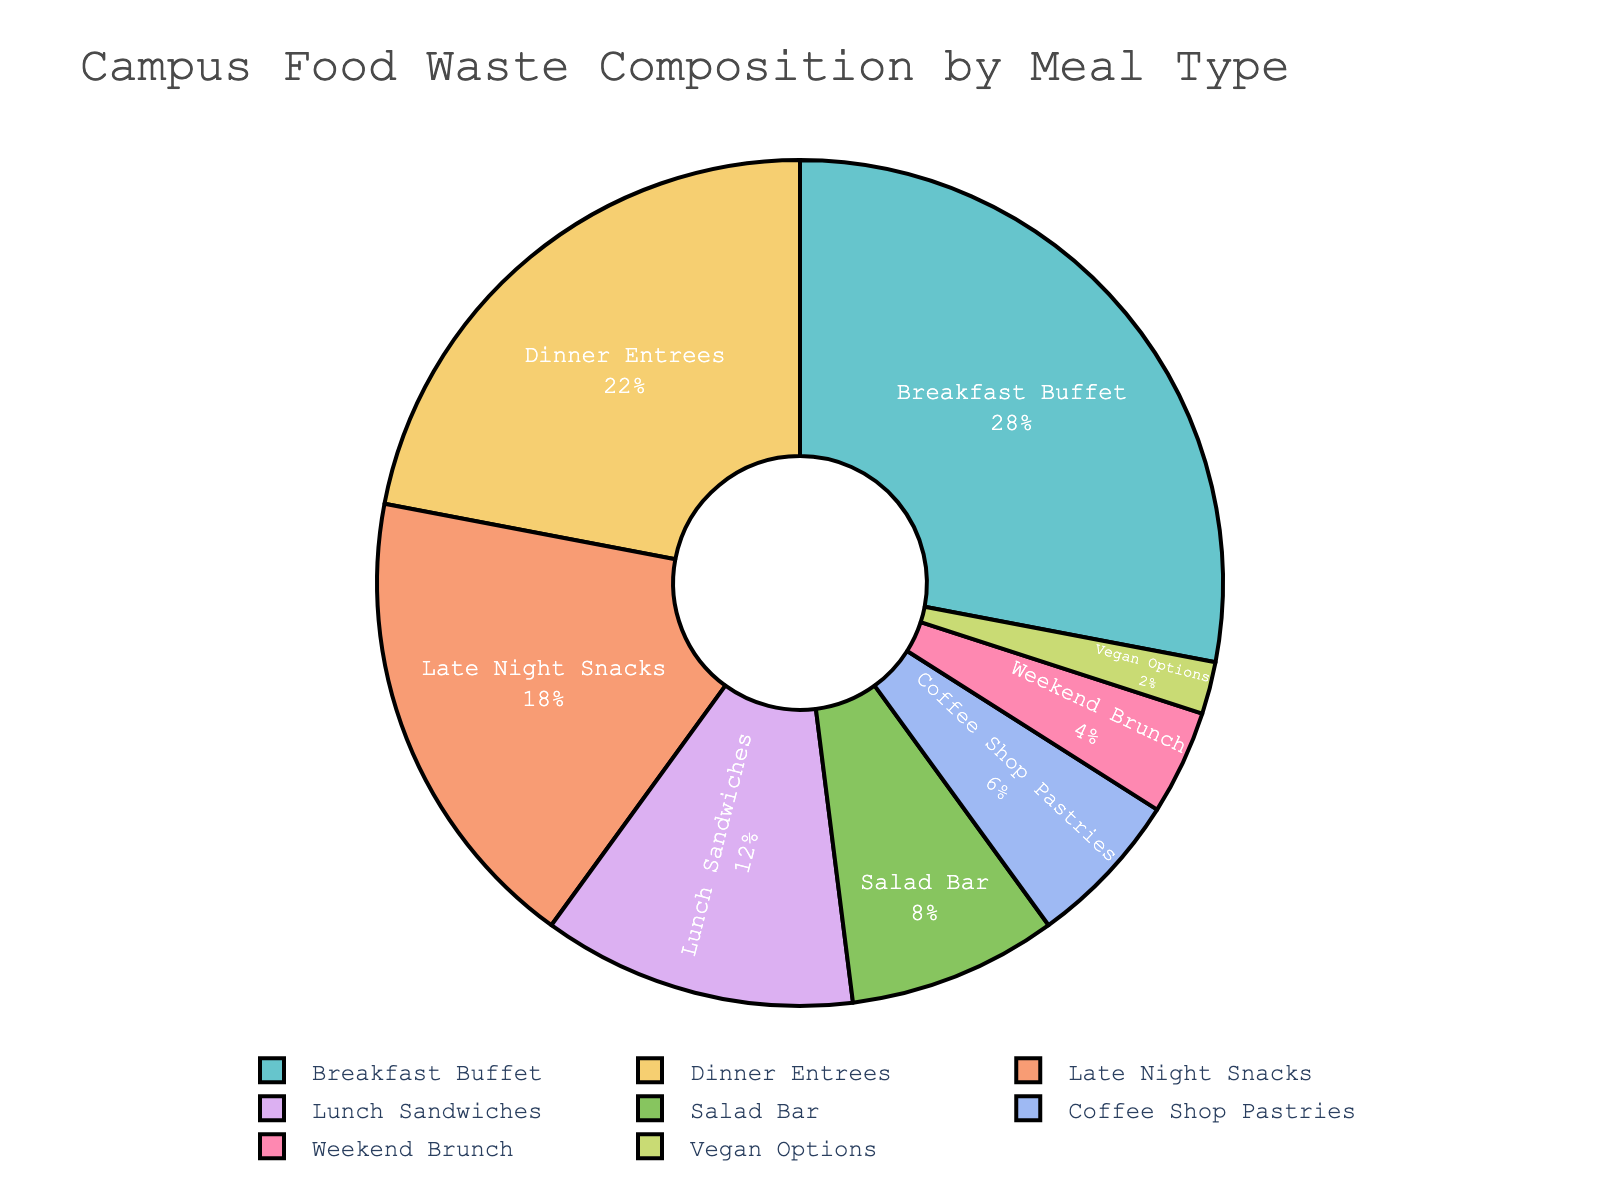What percentage of campus food waste is composed of breakfast items? Refer to the portion labeled "Breakfast Buffet" on the pie chart, which represents 28%.
Answer: 28% Which meal type contributes the smallest percentage to campus food waste? Identify the smallest segment in the pie chart, which is labeled "Vegan Options" and represents 2%.
Answer: Vegan Options How much more food waste is generated by dinner entrees compared to lunch sandwiches? Dinner Entrees contribute 22%, and Lunch Sandwiches contribute 12%. Subtract 12% from 22% to find the difference.
Answer: 10% If we combine the food waste from salad bars and coffee shop pastries, what percentage do they contribute together? Salad Bar and Coffee Shop Pastries contribute 8% and 6% respectively. Adding both percentages gives 8% + 6% = 14%.
Answer: 14% Which meal type has a nearly similar contribution to late-night snacks? Compare the percentages: Late Night Snacks have 18%, and Dinner Entrees have 22%, which is a close match.
Answer: Dinner Entrees How much less food waste does weekend brunch generate compared to breakfast buffets? Breakfast Buffet contributes 28%, and Weekend Brunch contributes 4%. Subtract 4% from 28% to find the difference.
Answer: 24% What is the combined percentage of vegan options, weekend brunch, and coffee shop pastries? Vegan Options are 2%, Weekend Brunch is 4%, and Coffee Shop Pastries are 6%. Adding them together gives 2% + 4% + 6% = 12%.
Answer: 12% Out of salad bar and lunch sandwiches, which generates more food waste? Compare the segments labeled "Salad Bar" at 8% and "Lunch Sandwiches" at 12%. Lunch Sandwiches have a higher percentage.
Answer: Lunch Sandwiches Which three meal types together account for more than half of the total food waste? Sum the top three contributors: Breakfast Buffet (28%), Dinner Entrees (22%), and Late Night Snacks (18%). 28% + 22% + 18% = 68%, which is more than half.
Answer: Breakfast Buffet, Dinner Entrees, Late Night Snacks 